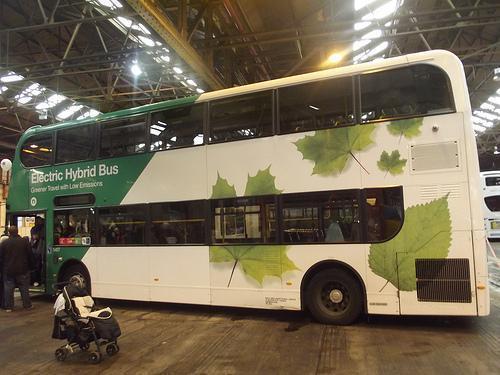How many buses are there?
Give a very brief answer. 1. 